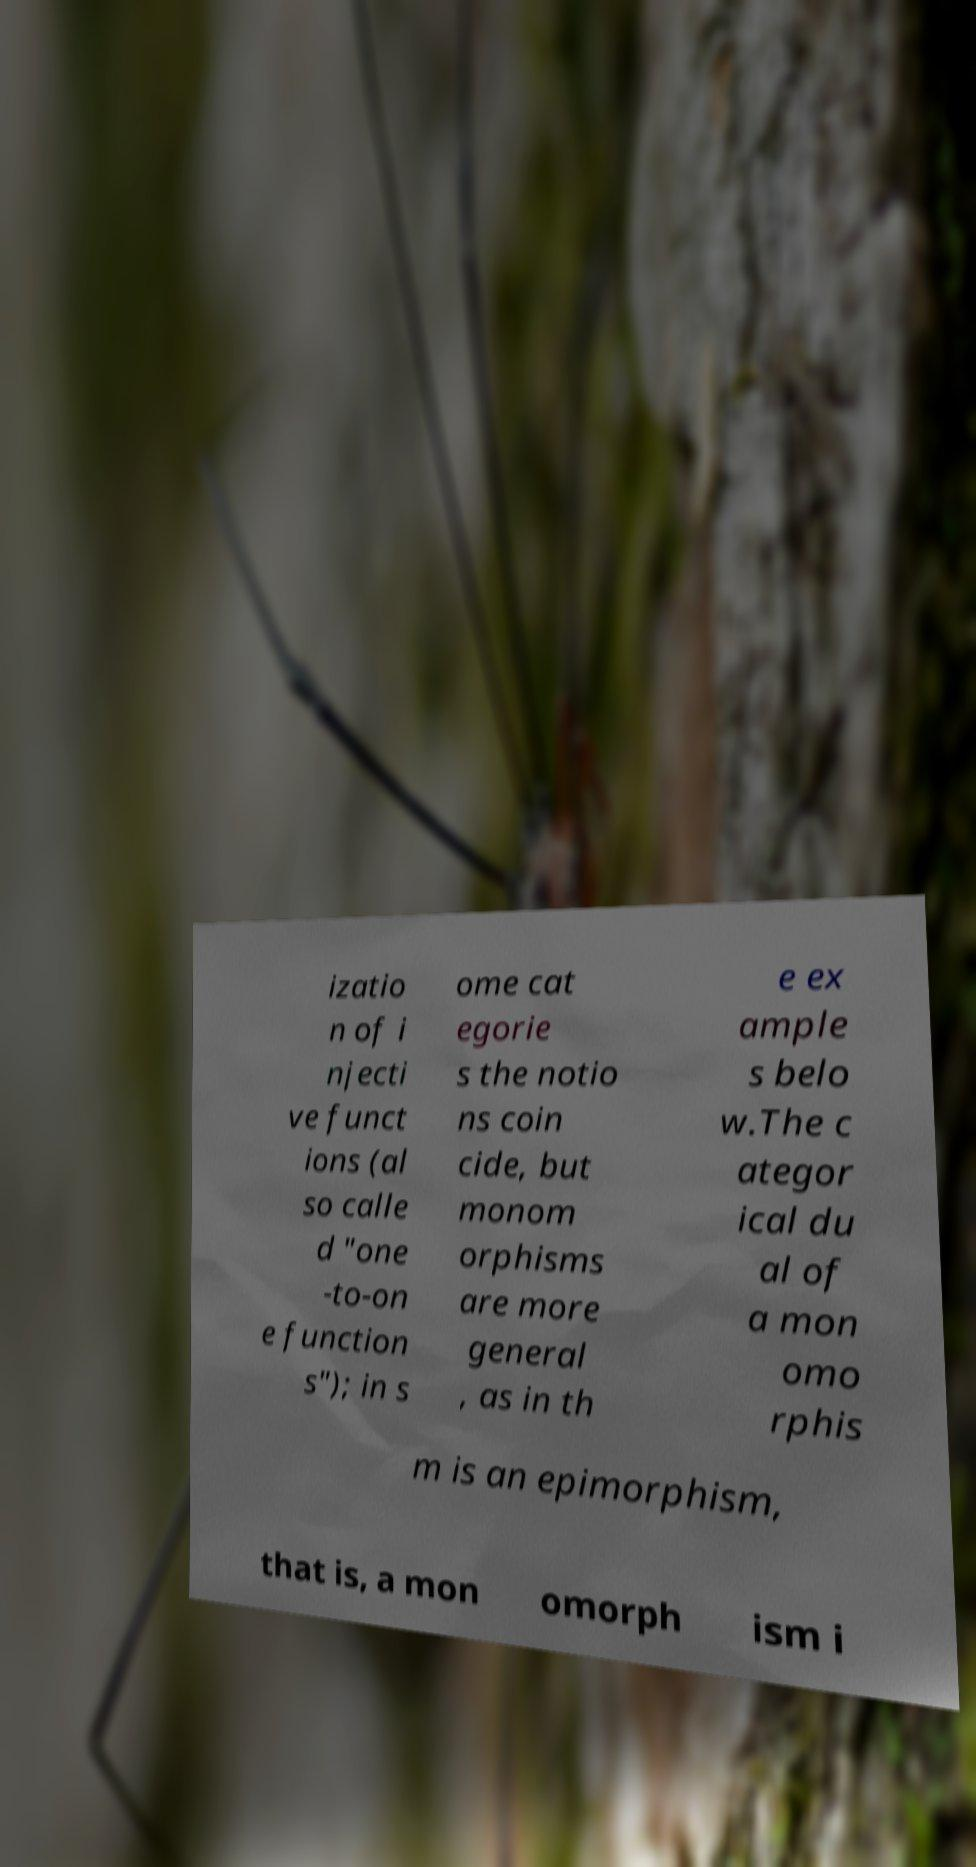What messages or text are displayed in this image? I need them in a readable, typed format. izatio n of i njecti ve funct ions (al so calle d "one -to-on e function s"); in s ome cat egorie s the notio ns coin cide, but monom orphisms are more general , as in th e ex ample s belo w.The c ategor ical du al of a mon omo rphis m is an epimorphism, that is, a mon omorph ism i 